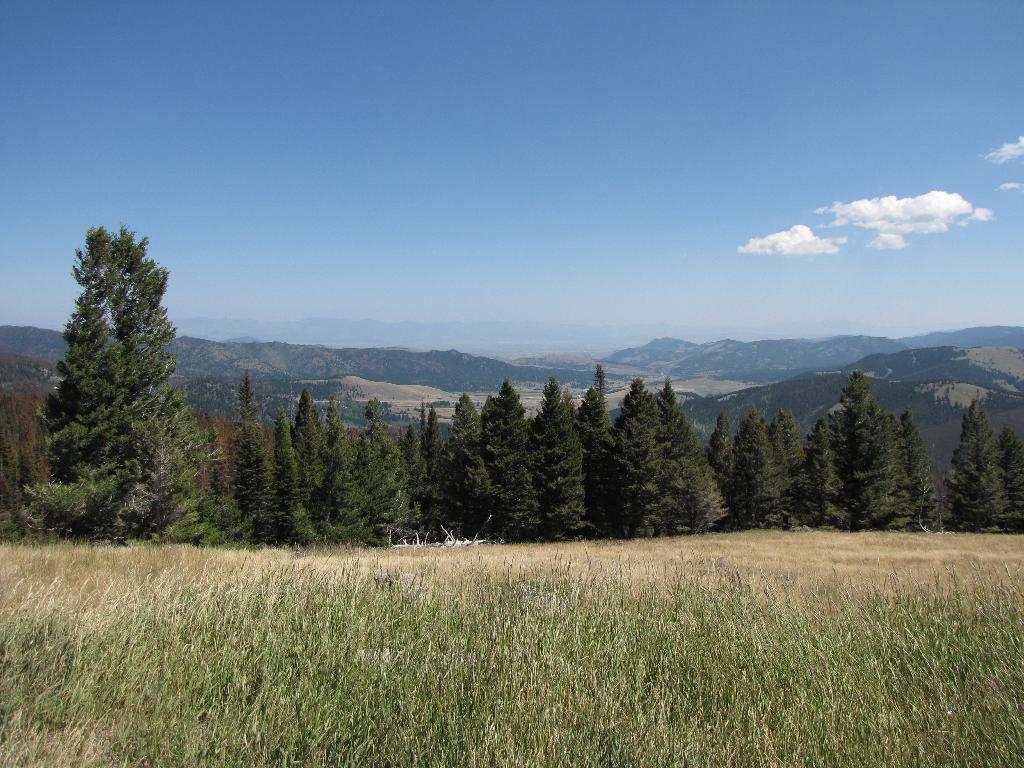How would you summarize this image in a sentence or two? In this image I can see trees and grass in green color, background I can see mountains and the sky is in blue and white color. 